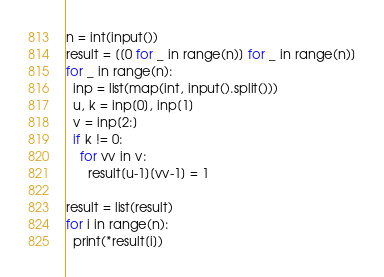<code> <loc_0><loc_0><loc_500><loc_500><_Python_>n = int(input())
result = [[0 for _ in range(n)] for _ in range(n)]
for _ in range(n):
  inp = list(map(int, input().split()))
  u, k = inp[0], inp[1]
  v = inp[2:]
  if k != 0:
    for vv in v:
      result[u-1][vv-1] = 1

result = list(result)
for i in range(n):
  print(*result[i])
</code> 